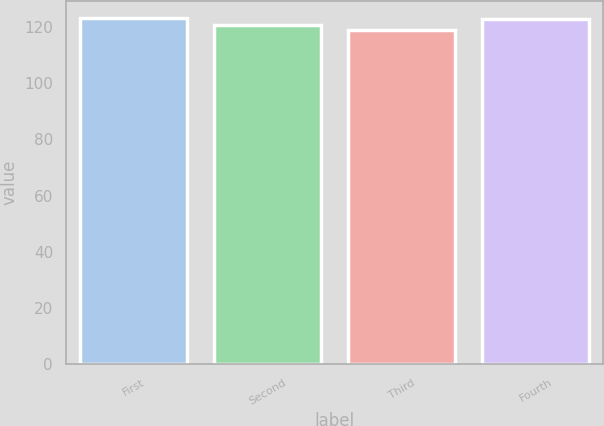<chart> <loc_0><loc_0><loc_500><loc_500><bar_chart><fcel>First<fcel>Second<fcel>Third<fcel>Fourth<nl><fcel>123.08<fcel>120.61<fcel>118.87<fcel>122.64<nl></chart> 